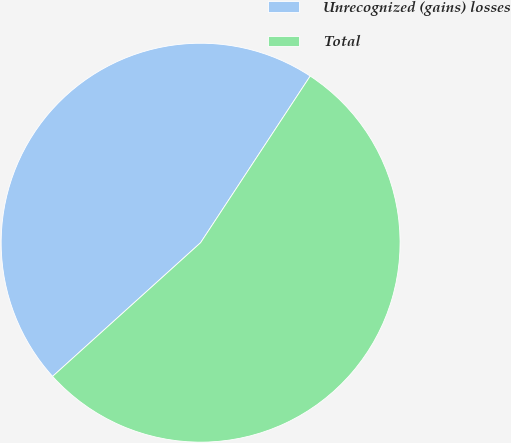Convert chart. <chart><loc_0><loc_0><loc_500><loc_500><pie_chart><fcel>Unrecognized (gains) losses<fcel>Total<nl><fcel>45.95%<fcel>54.05%<nl></chart> 